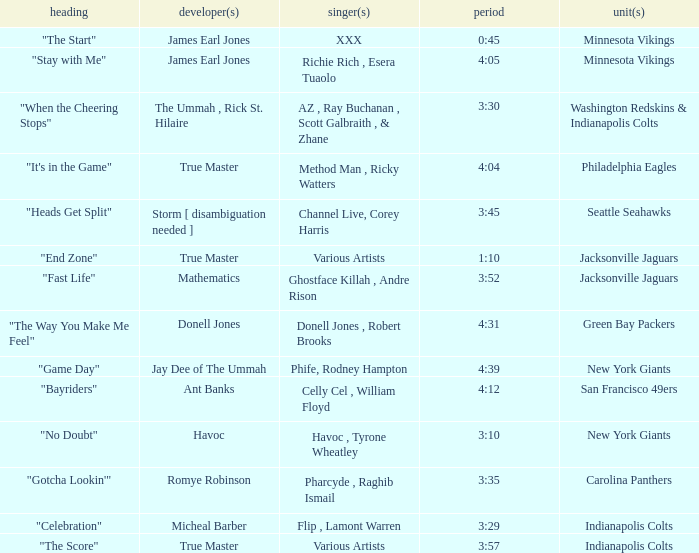Who is the artist of the New York Giants track "No Doubt"? Havoc , Tyrone Wheatley. 